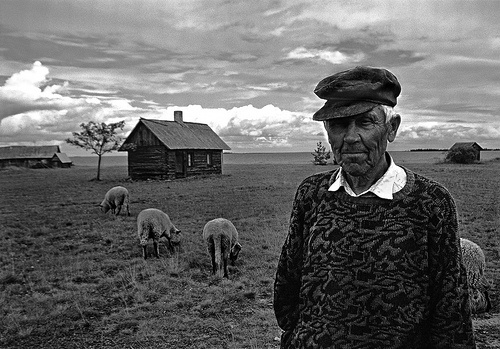Describe the objects in this image and their specific colors. I can see people in gray, black, lightgray, and darkgray tones, sheep in gray, black, and lightgray tones, sheep in gray, black, and lightgray tones, sheep in gray, darkgray, black, and lightgray tones, and sheep in black and gray tones in this image. 